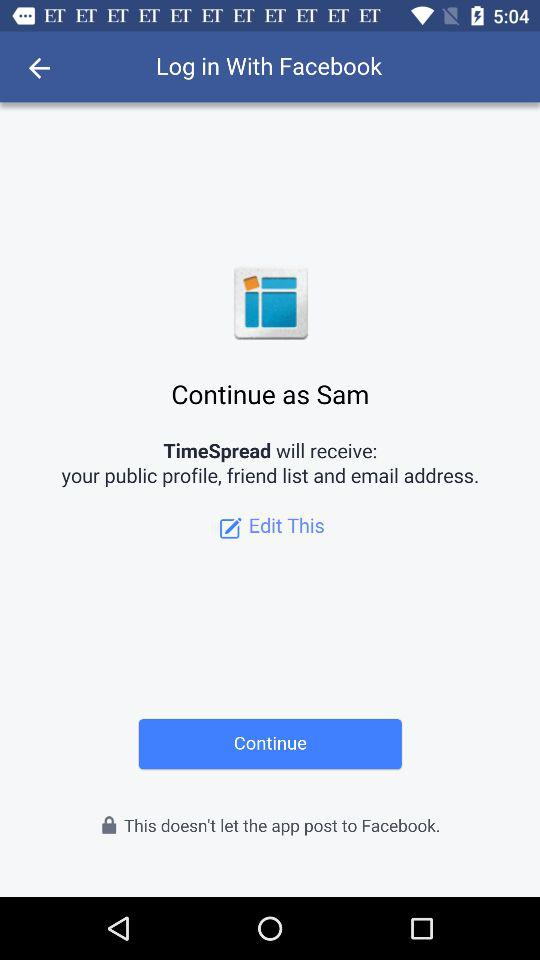Through what application can logging in be done? It can be done through "Facebook". 